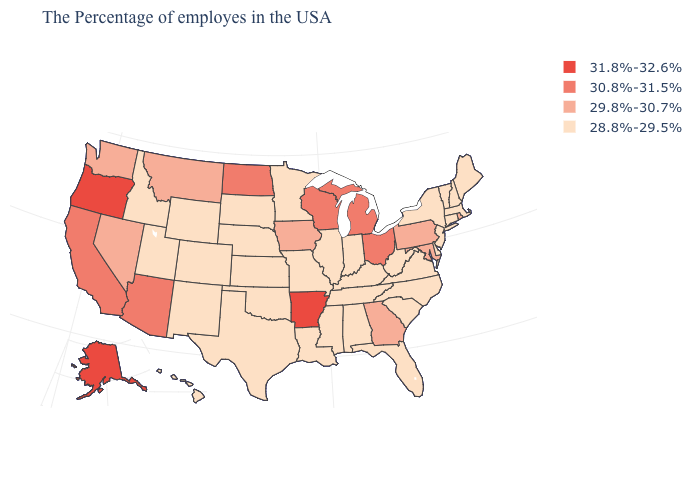Name the states that have a value in the range 31.8%-32.6%?
Keep it brief. Arkansas, Oregon, Alaska. What is the value of Louisiana?
Write a very short answer. 28.8%-29.5%. Name the states that have a value in the range 29.8%-30.7%?
Give a very brief answer. Rhode Island, Maryland, Pennsylvania, Georgia, Iowa, Montana, Nevada, Washington. Among the states that border Virginia , does West Virginia have the lowest value?
Give a very brief answer. Yes. Name the states that have a value in the range 30.8%-31.5%?
Give a very brief answer. Ohio, Michigan, Wisconsin, North Dakota, Arizona, California. Name the states that have a value in the range 31.8%-32.6%?
Be succinct. Arkansas, Oregon, Alaska. What is the value of Connecticut?
Answer briefly. 28.8%-29.5%. Name the states that have a value in the range 30.8%-31.5%?
Write a very short answer. Ohio, Michigan, Wisconsin, North Dakota, Arizona, California. Which states have the lowest value in the Northeast?
Be succinct. Maine, Massachusetts, New Hampshire, Vermont, Connecticut, New York, New Jersey. Which states hav the highest value in the Northeast?
Answer briefly. Rhode Island, Pennsylvania. What is the lowest value in states that border Montana?
Quick response, please. 28.8%-29.5%. Does West Virginia have the highest value in the South?
Keep it brief. No. Name the states that have a value in the range 30.8%-31.5%?
Be succinct. Ohio, Michigan, Wisconsin, North Dakota, Arizona, California. Among the states that border Florida , does Georgia have the lowest value?
Short answer required. No. Does Idaho have a lower value than New York?
Concise answer only. No. 